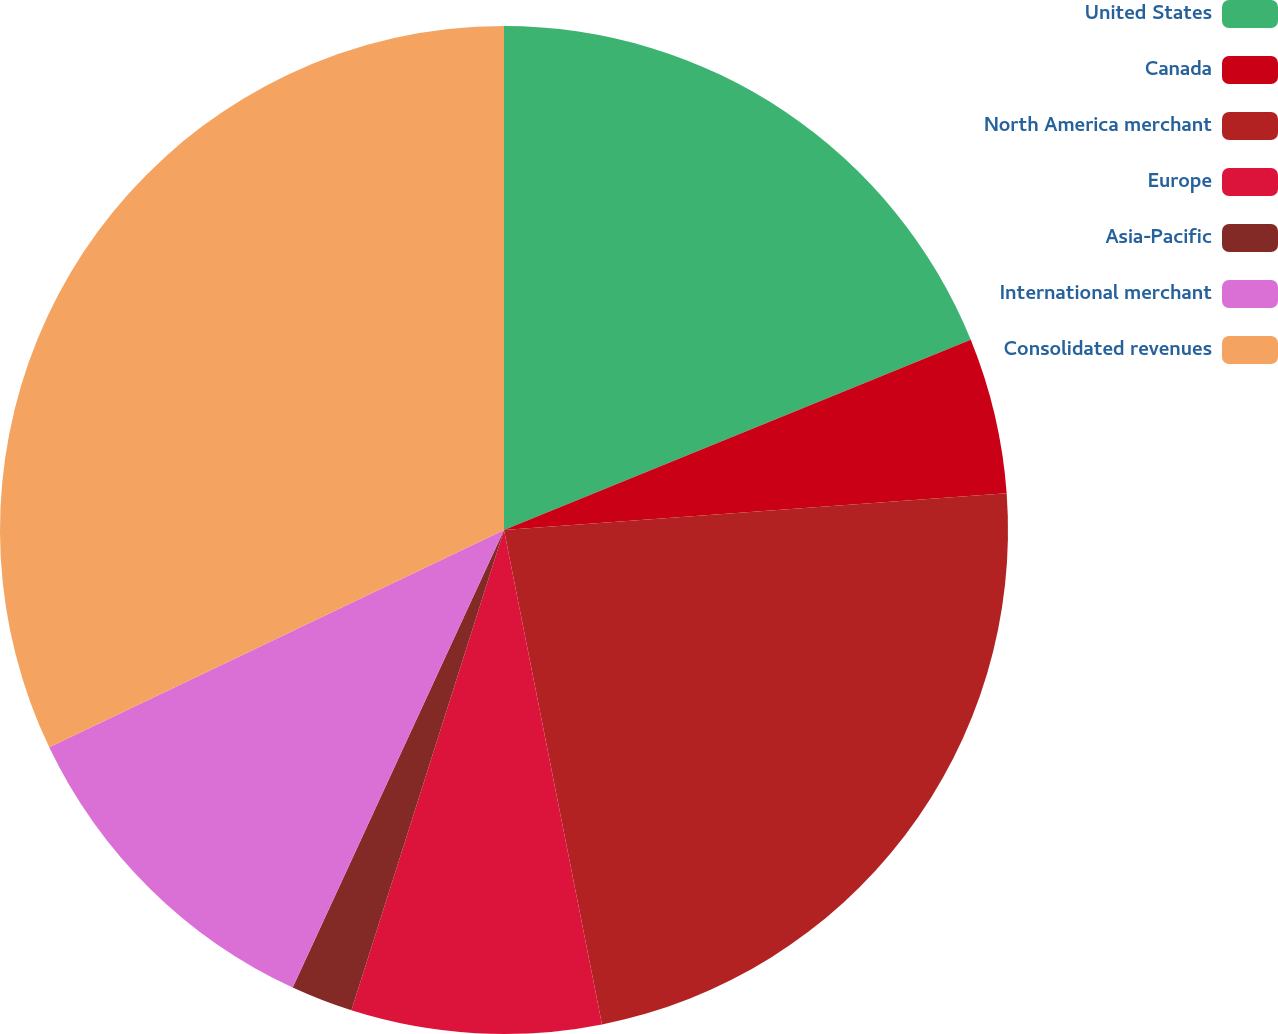Convert chart. <chart><loc_0><loc_0><loc_500><loc_500><pie_chart><fcel>United States<fcel>Canada<fcel>North America merchant<fcel>Europe<fcel>Asia-Pacific<fcel>International merchant<fcel>Consolidated revenues<nl><fcel>18.84%<fcel>5.0%<fcel>23.04%<fcel>8.01%<fcel>1.99%<fcel>11.02%<fcel>32.09%<nl></chart> 